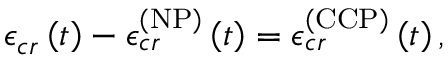<formula> <loc_0><loc_0><loc_500><loc_500>\mathcal { \epsilon } _ { c r } \left ( t \right ) - \mathcal { \epsilon } _ { c r } ^ { \left ( N P \right ) } \left ( t \right ) = \mathcal { \epsilon } _ { c r } ^ { \left ( C C P \right ) } \left ( t \right ) ,</formula> 